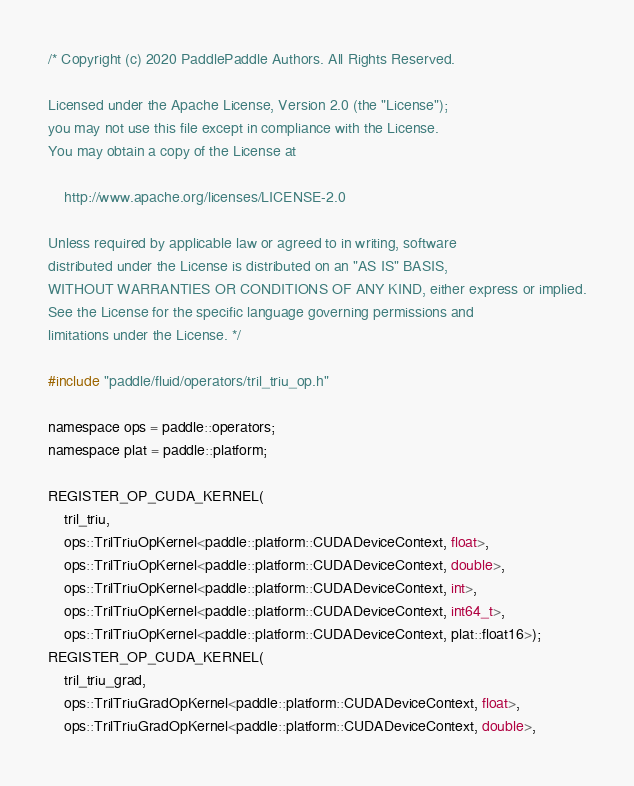<code> <loc_0><loc_0><loc_500><loc_500><_Cuda_>/* Copyright (c) 2020 PaddlePaddle Authors. All Rights Reserved.

Licensed under the Apache License, Version 2.0 (the "License");
you may not use this file except in compliance with the License.
You may obtain a copy of the License at

    http://www.apache.org/licenses/LICENSE-2.0

Unless required by applicable law or agreed to in writing, software
distributed under the License is distributed on an "AS IS" BASIS,
WITHOUT WARRANTIES OR CONDITIONS OF ANY KIND, either express or implied.
See the License for the specific language governing permissions and
limitations under the License. */

#include "paddle/fluid/operators/tril_triu_op.h"

namespace ops = paddle::operators;
namespace plat = paddle::platform;

REGISTER_OP_CUDA_KERNEL(
    tril_triu,
    ops::TrilTriuOpKernel<paddle::platform::CUDADeviceContext, float>,
    ops::TrilTriuOpKernel<paddle::platform::CUDADeviceContext, double>,
    ops::TrilTriuOpKernel<paddle::platform::CUDADeviceContext, int>,
    ops::TrilTriuOpKernel<paddle::platform::CUDADeviceContext, int64_t>,
    ops::TrilTriuOpKernel<paddle::platform::CUDADeviceContext, plat::float16>);
REGISTER_OP_CUDA_KERNEL(
    tril_triu_grad,
    ops::TrilTriuGradOpKernel<paddle::platform::CUDADeviceContext, float>,
    ops::TrilTriuGradOpKernel<paddle::platform::CUDADeviceContext, double>,</code> 